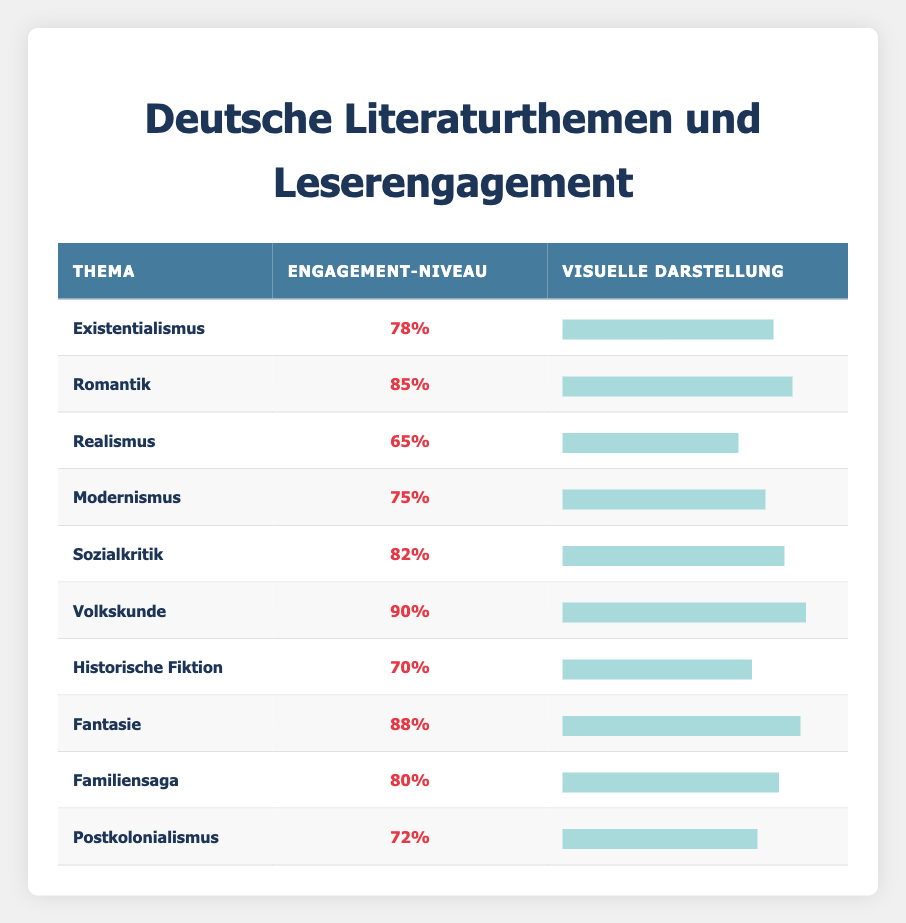What is the engagement level of the theme "Fantasy"? The engagement level for "Fantasy" is found directly in the table, which states the engagement level as 88%.
Answer: 88% Which theme has the highest reader engagement level? By examining the engagement levels in each row of the table, it's clear that the theme "Folklore" has the highest engagement level at 90%.
Answer: Folklore What is the average engagement level of the themes "Romanticism," "Social Critique," and "Fantasy"? The engagement levels for these themes are 85%, 82%, and 88%, respectively. Adding these together gives 85 + 82 + 88 = 255. There are 3 themes, so dividing by 3 results in an average engagement level of 255 / 3 = 85.
Answer: 85 Is the engagement level of "Realism" higher than that of "Historical Fiction"? The engagement level for "Realism" is 65%, while for "Historical Fiction," it is 70%. Since 65 is not greater than 70, the answer is no.
Answer: No Which theme has a lower engagement level: "Postcolonialism" or "Modernism"? Referring to the respective engagement levels, "Postcolonialism" has a level of 72%, and "Modernism" has 75%. Since 72% is less than 75%, "Postcolonialism" has the lower engagement level.
Answer: Postcolonialism 